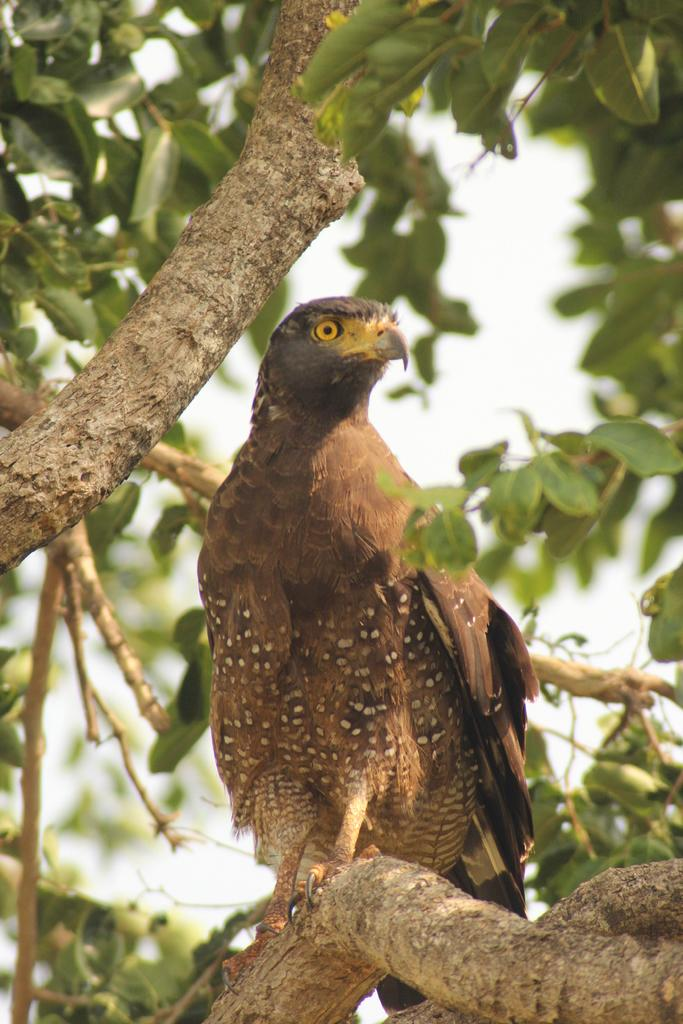What type of animal can be seen in the image? There is a bird in the image. Where is the bird located in the image? The bird is on a branch. What else can be seen on the branch in the image? There are branches visible in the image. What type of vegetation is present in the image? There are leaves visible in the image. What type of sound can be heard coming from the bird in the image? There is no sound present in the image, so it cannot be determined what sound the bird might be making. 